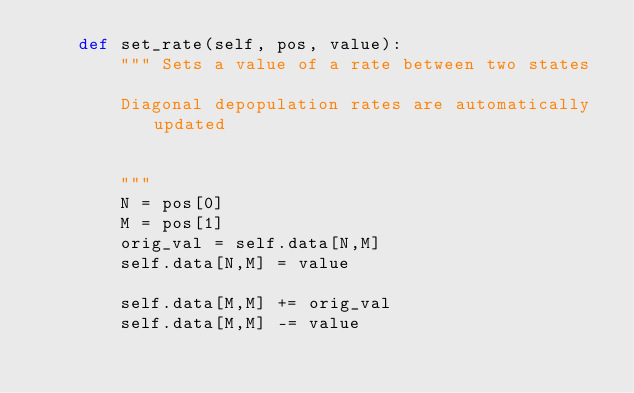Convert code to text. <code><loc_0><loc_0><loc_500><loc_500><_Python_>    def set_rate(self, pos, value):
        """ Sets a value of a rate between two states
        
        Diagonal depopulation rates are automatically updated
        
        
        """
        N = pos[0]
        M = pos[1]
        orig_val = self.data[N,M]
        self.data[N,M] = value
        
        self.data[M,M] += orig_val
        self.data[M,M] -= value
        
        </code> 